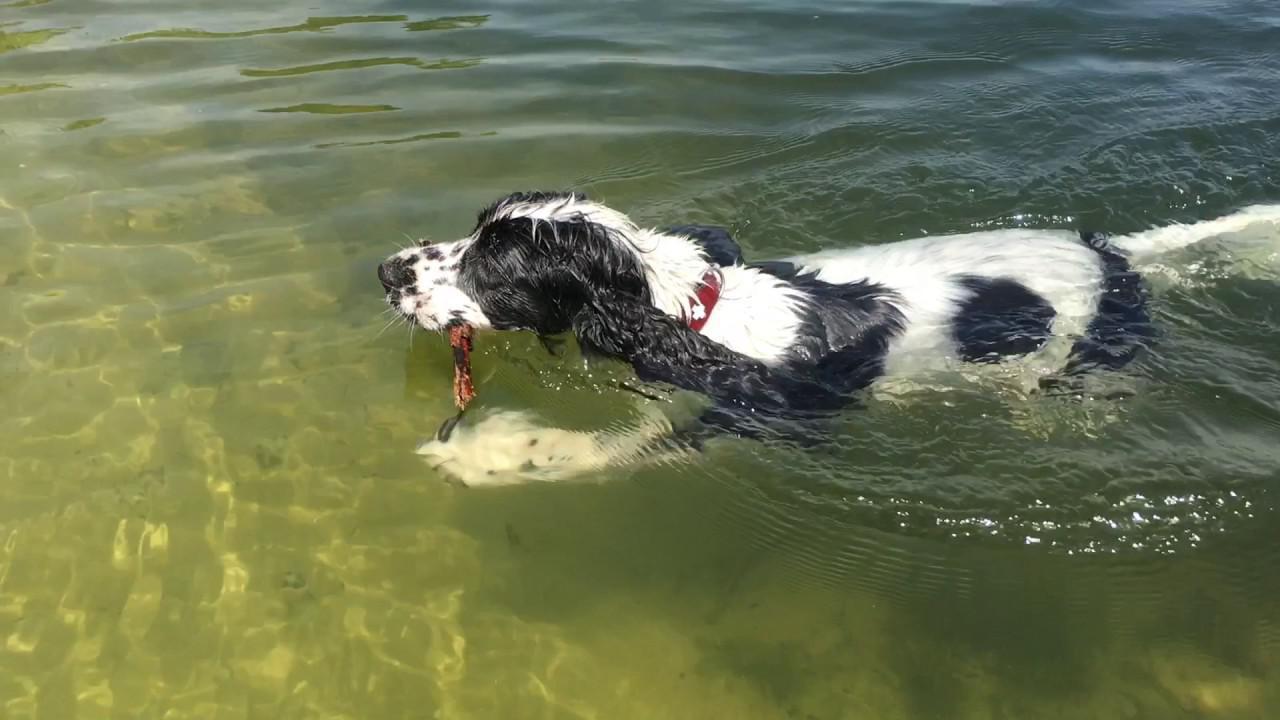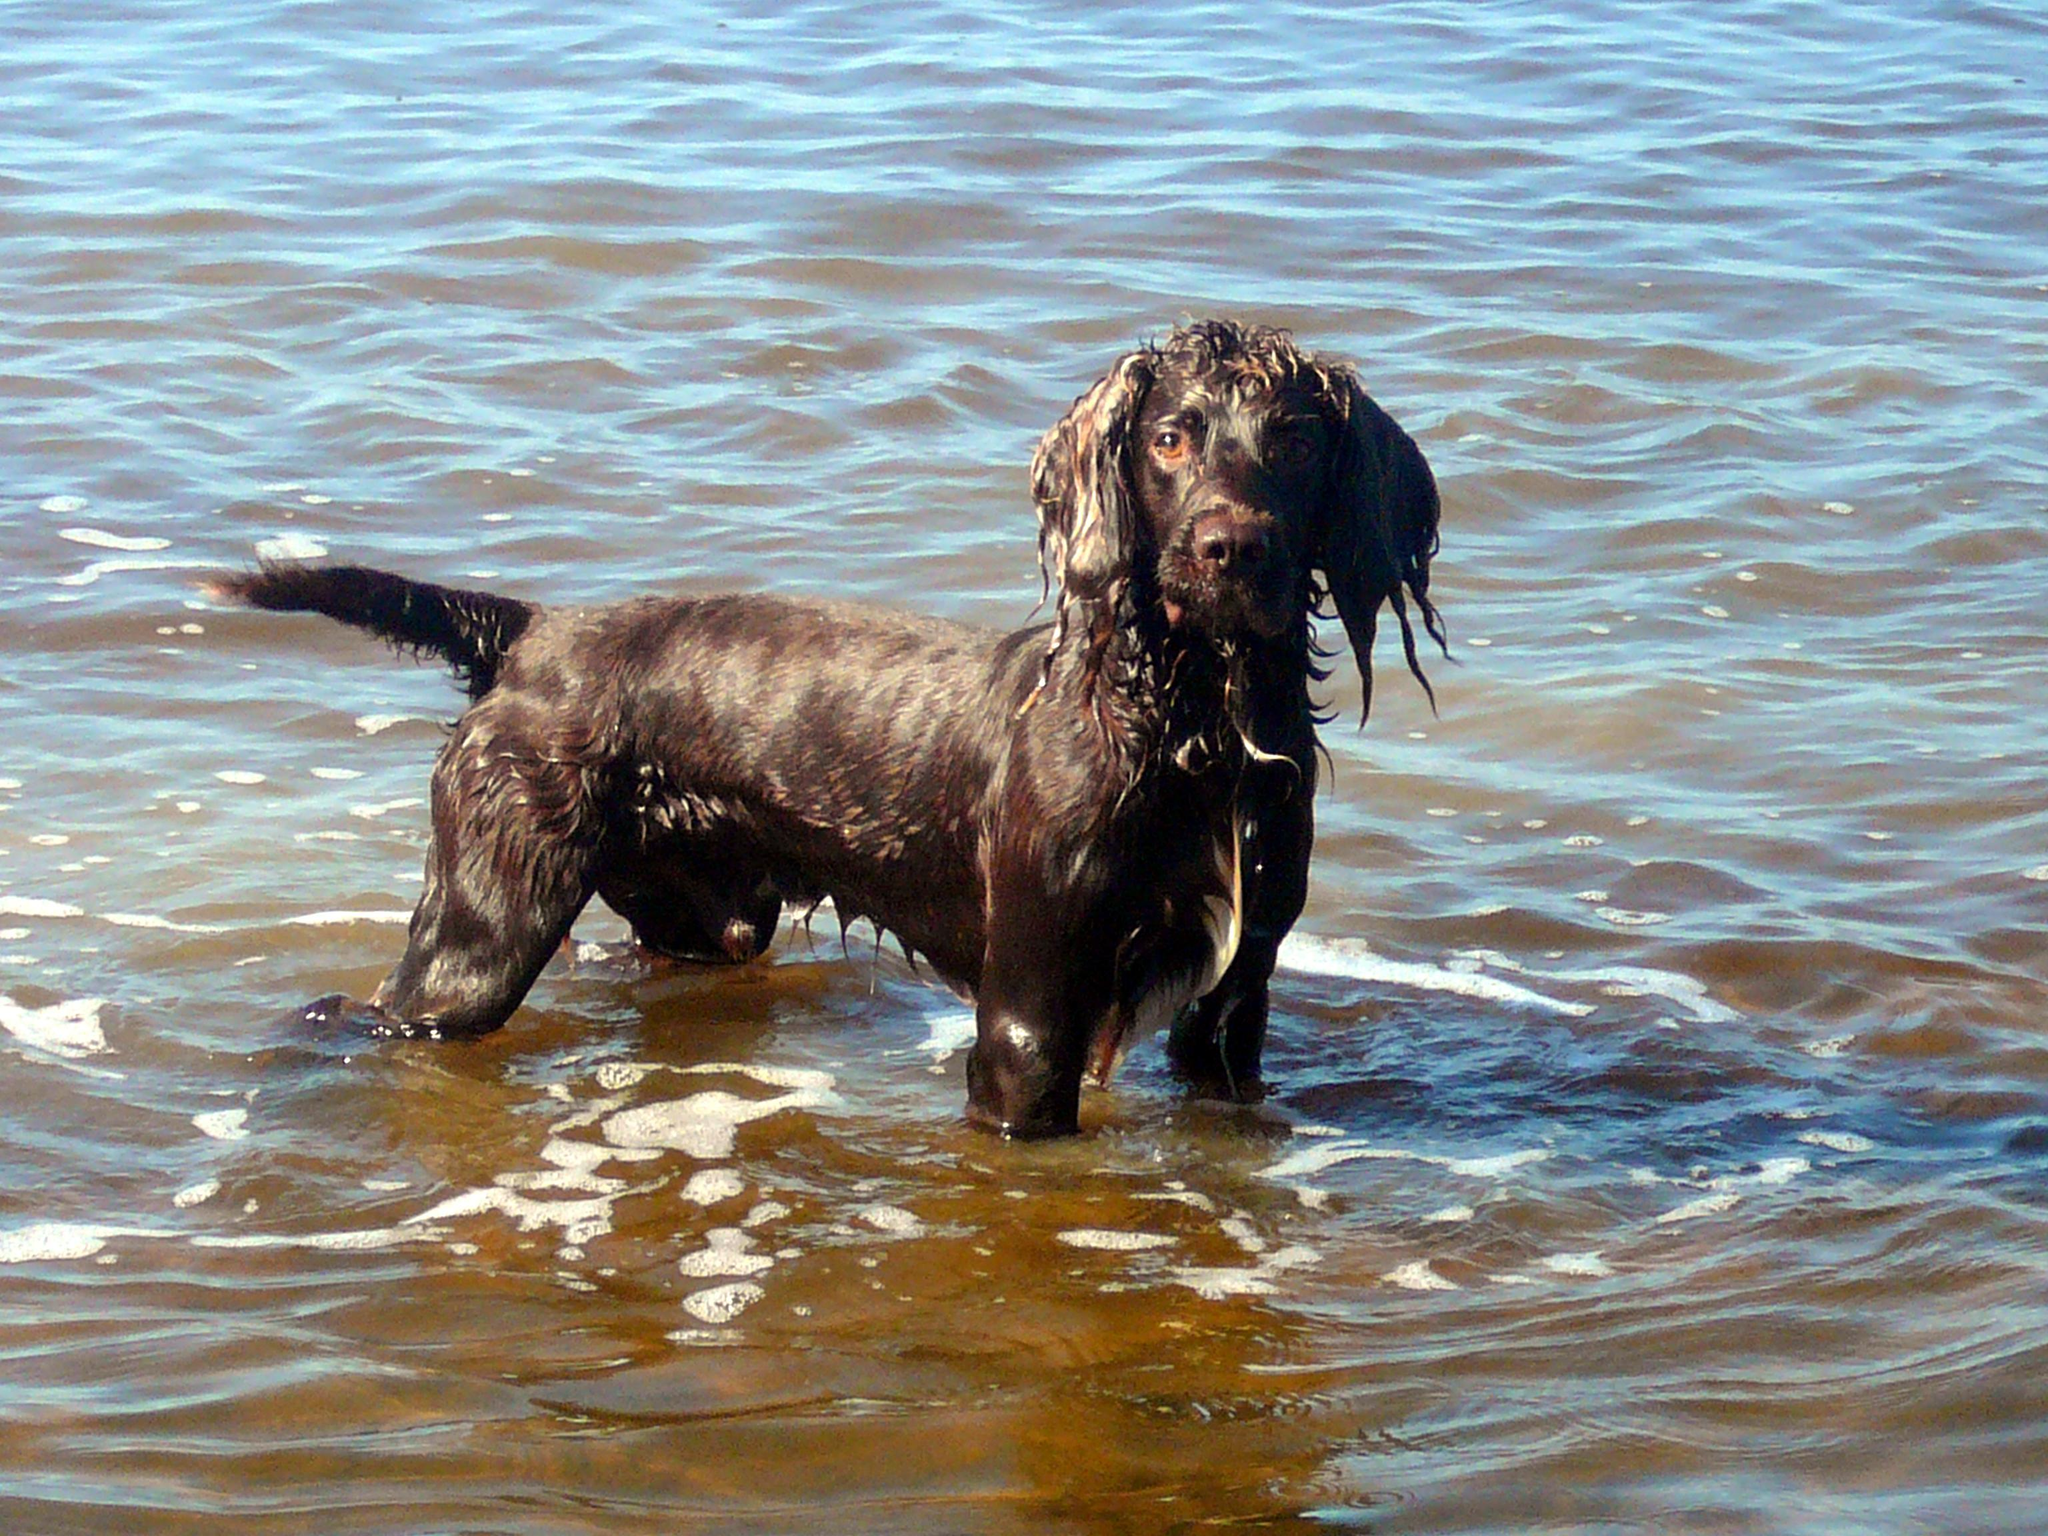The first image is the image on the left, the second image is the image on the right. Given the left and right images, does the statement "The dog in the image on the right is standing in the water." hold true? Answer yes or no. Yes. The first image is the image on the left, the second image is the image on the right. Considering the images on both sides, is "An image shows a dog swimming leftward with a stick-shaped object in its mouth." valid? Answer yes or no. Yes. 